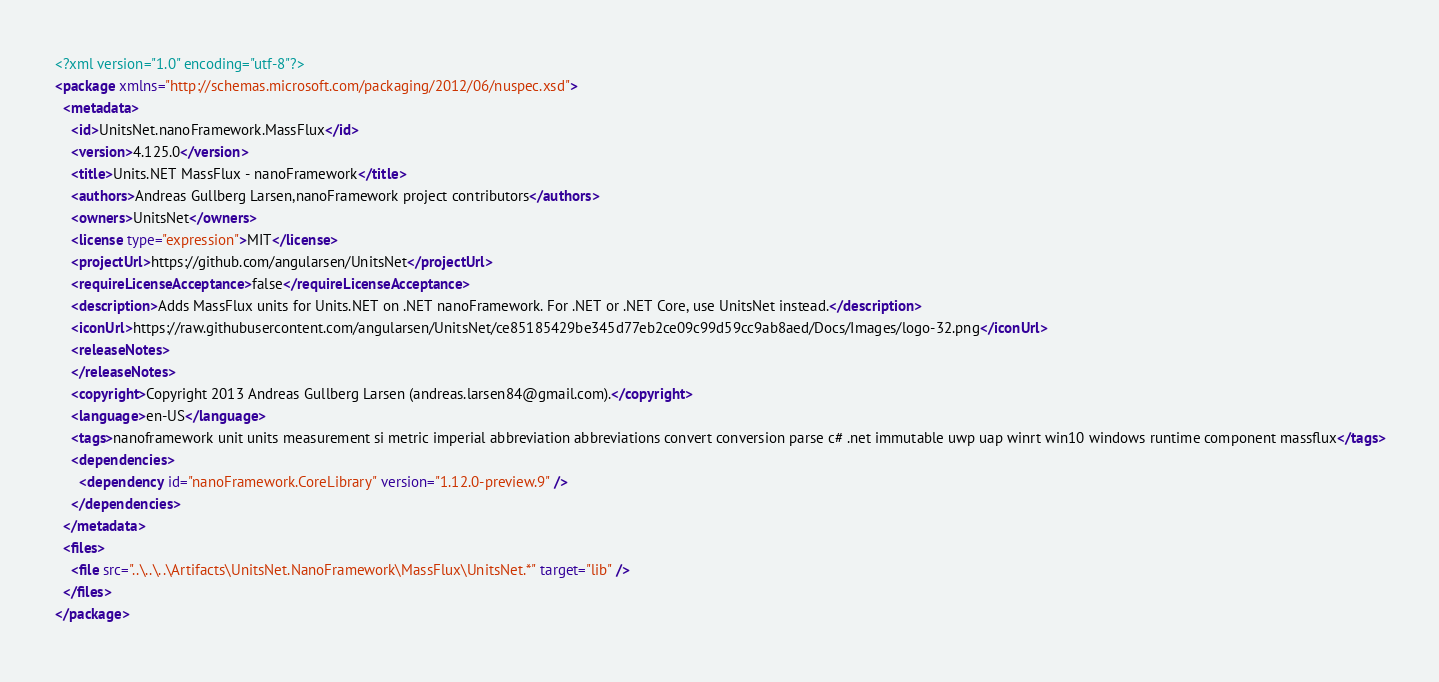<code> <loc_0><loc_0><loc_500><loc_500><_XML_><?xml version="1.0" encoding="utf-8"?>
<package xmlns="http://schemas.microsoft.com/packaging/2012/06/nuspec.xsd">
  <metadata>
    <id>UnitsNet.nanoFramework.MassFlux</id>
    <version>4.125.0</version>
    <title>Units.NET MassFlux - nanoFramework</title>
    <authors>Andreas Gullberg Larsen,nanoFramework project contributors</authors>
    <owners>UnitsNet</owners>
    <license type="expression">MIT</license>
    <projectUrl>https://github.com/angularsen/UnitsNet</projectUrl>
    <requireLicenseAcceptance>false</requireLicenseAcceptance>
    <description>Adds MassFlux units for Units.NET on .NET nanoFramework. For .NET or .NET Core, use UnitsNet instead.</description>
    <iconUrl>https://raw.githubusercontent.com/angularsen/UnitsNet/ce85185429be345d77eb2ce09c99d59cc9ab8aed/Docs/Images/logo-32.png</iconUrl>
    <releaseNotes>
    </releaseNotes>
    <copyright>Copyright 2013 Andreas Gullberg Larsen (andreas.larsen84@gmail.com).</copyright>
    <language>en-US</language>
    <tags>nanoframework unit units measurement si metric imperial abbreviation abbreviations convert conversion parse c# .net immutable uwp uap winrt win10 windows runtime component massflux</tags>
    <dependencies>
      <dependency id="nanoFramework.CoreLibrary" version="1.12.0-preview.9" />
    </dependencies>
  </metadata>
  <files>
    <file src="..\..\..\Artifacts\UnitsNet.NanoFramework\MassFlux\UnitsNet.*" target="lib" />
  </files>
</package>
</code> 